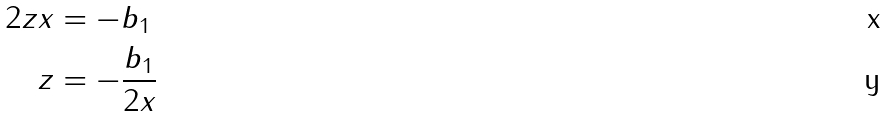<formula> <loc_0><loc_0><loc_500><loc_500>2 z x & = - b _ { 1 } \\ z & = - \frac { b _ { 1 } } { 2 x }</formula> 